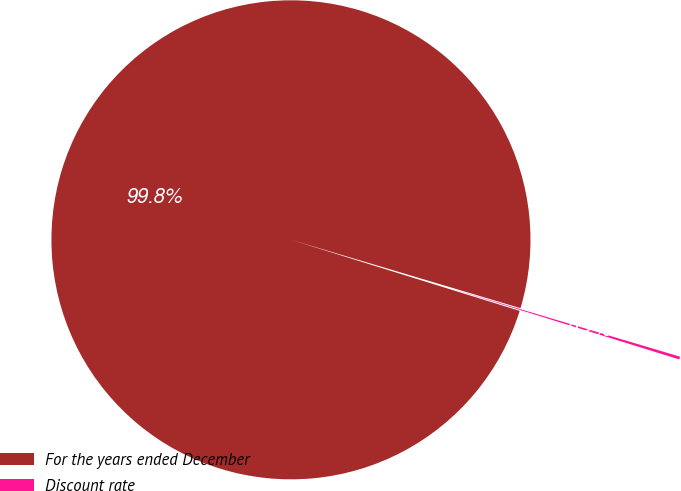Convert chart. <chart><loc_0><loc_0><loc_500><loc_500><pie_chart><fcel>For the years ended December<fcel>Discount rate<nl><fcel>99.81%<fcel>0.19%<nl></chart> 